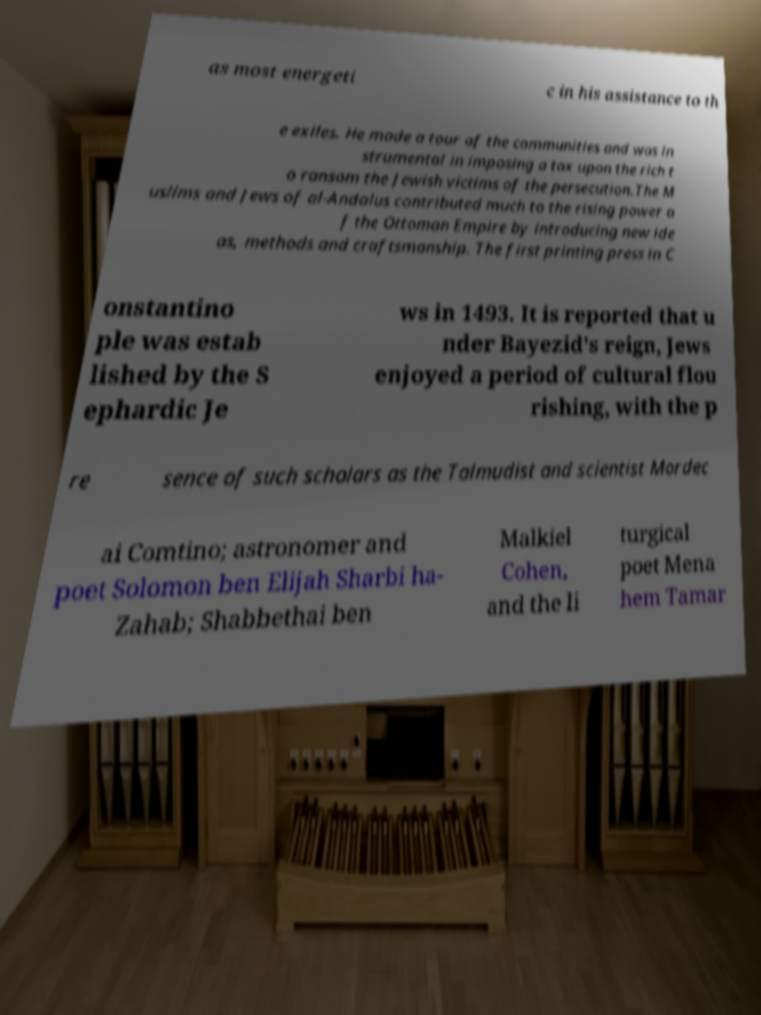For documentation purposes, I need the text within this image transcribed. Could you provide that? as most energeti c in his assistance to th e exiles. He made a tour of the communities and was in strumental in imposing a tax upon the rich t o ransom the Jewish victims of the persecution.The M uslims and Jews of al-Andalus contributed much to the rising power o f the Ottoman Empire by introducing new ide as, methods and craftsmanship. The first printing press in C onstantino ple was estab lished by the S ephardic Je ws in 1493. It is reported that u nder Bayezid's reign, Jews enjoyed a period of cultural flou rishing, with the p re sence of such scholars as the Talmudist and scientist Mordec ai Comtino; astronomer and poet Solomon ben Elijah Sharbi ha- Zahab; Shabbethai ben Malkiel Cohen, and the li turgical poet Mena hem Tamar 